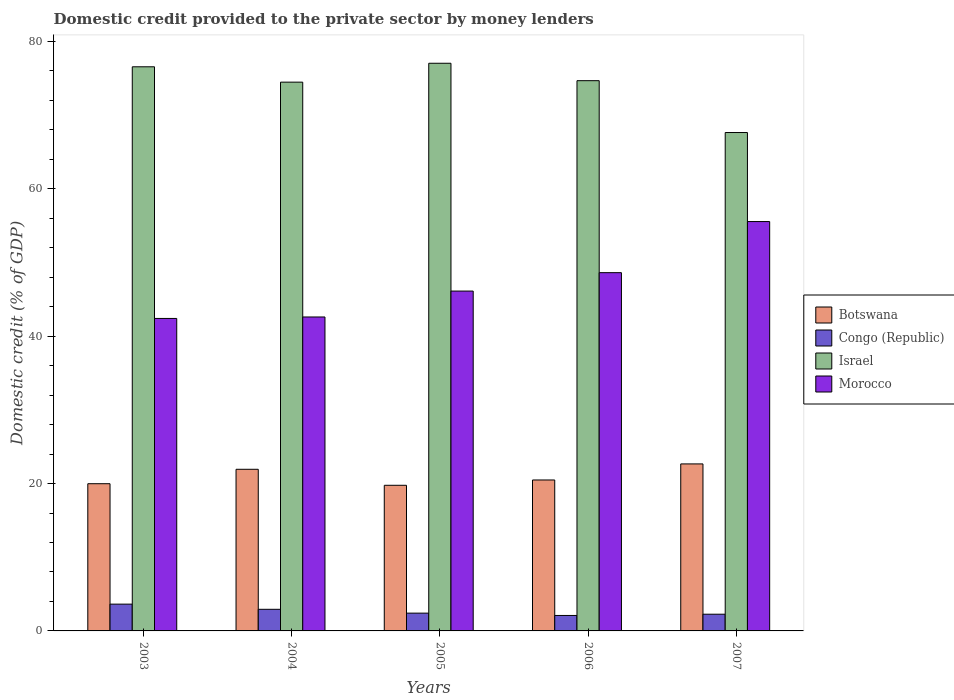How many different coloured bars are there?
Give a very brief answer. 4. Are the number of bars per tick equal to the number of legend labels?
Offer a very short reply. Yes. Are the number of bars on each tick of the X-axis equal?
Give a very brief answer. Yes. How many bars are there on the 1st tick from the left?
Provide a succinct answer. 4. How many bars are there on the 5th tick from the right?
Keep it short and to the point. 4. What is the label of the 4th group of bars from the left?
Keep it short and to the point. 2006. In how many cases, is the number of bars for a given year not equal to the number of legend labels?
Provide a short and direct response. 0. What is the domestic credit provided to the private sector by money lenders in Israel in 2006?
Your answer should be compact. 74.67. Across all years, what is the maximum domestic credit provided to the private sector by money lenders in Morocco?
Provide a succinct answer. 55.55. Across all years, what is the minimum domestic credit provided to the private sector by money lenders in Congo (Republic)?
Your answer should be very brief. 2.1. In which year was the domestic credit provided to the private sector by money lenders in Israel minimum?
Ensure brevity in your answer.  2007. What is the total domestic credit provided to the private sector by money lenders in Botswana in the graph?
Keep it short and to the point. 104.83. What is the difference between the domestic credit provided to the private sector by money lenders in Botswana in 2004 and that in 2007?
Provide a succinct answer. -0.73. What is the difference between the domestic credit provided to the private sector by money lenders in Congo (Republic) in 2007 and the domestic credit provided to the private sector by money lenders in Botswana in 2005?
Your answer should be very brief. -17.5. What is the average domestic credit provided to the private sector by money lenders in Congo (Republic) per year?
Your answer should be compact. 2.67. In the year 2003, what is the difference between the domestic credit provided to the private sector by money lenders in Congo (Republic) and domestic credit provided to the private sector by money lenders in Botswana?
Give a very brief answer. -16.34. In how many years, is the domestic credit provided to the private sector by money lenders in Morocco greater than 68 %?
Keep it short and to the point. 0. What is the ratio of the domestic credit provided to the private sector by money lenders in Israel in 2004 to that in 2005?
Your response must be concise. 0.97. Is the domestic credit provided to the private sector by money lenders in Morocco in 2004 less than that in 2007?
Offer a very short reply. Yes. Is the difference between the domestic credit provided to the private sector by money lenders in Congo (Republic) in 2004 and 2006 greater than the difference between the domestic credit provided to the private sector by money lenders in Botswana in 2004 and 2006?
Ensure brevity in your answer.  No. What is the difference between the highest and the second highest domestic credit provided to the private sector by money lenders in Congo (Republic)?
Offer a very short reply. 0.7. What is the difference between the highest and the lowest domestic credit provided to the private sector by money lenders in Morocco?
Give a very brief answer. 13.15. What does the 4th bar from the left in 2004 represents?
Provide a short and direct response. Morocco. Is it the case that in every year, the sum of the domestic credit provided to the private sector by money lenders in Botswana and domestic credit provided to the private sector by money lenders in Israel is greater than the domestic credit provided to the private sector by money lenders in Congo (Republic)?
Provide a short and direct response. Yes. How many bars are there?
Your answer should be compact. 20. Are all the bars in the graph horizontal?
Your answer should be compact. No. Are the values on the major ticks of Y-axis written in scientific E-notation?
Your answer should be very brief. No. Does the graph contain any zero values?
Provide a short and direct response. No. Where does the legend appear in the graph?
Offer a very short reply. Center right. What is the title of the graph?
Offer a very short reply. Domestic credit provided to the private sector by money lenders. Does "Pacific island small states" appear as one of the legend labels in the graph?
Ensure brevity in your answer.  No. What is the label or title of the Y-axis?
Offer a very short reply. Domestic credit (% of GDP). What is the Domestic credit (% of GDP) of Botswana in 2003?
Your answer should be compact. 19.98. What is the Domestic credit (% of GDP) in Congo (Republic) in 2003?
Ensure brevity in your answer.  3.64. What is the Domestic credit (% of GDP) in Israel in 2003?
Ensure brevity in your answer.  76.56. What is the Domestic credit (% of GDP) of Morocco in 2003?
Offer a terse response. 42.41. What is the Domestic credit (% of GDP) in Botswana in 2004?
Ensure brevity in your answer.  21.94. What is the Domestic credit (% of GDP) of Congo (Republic) in 2004?
Ensure brevity in your answer.  2.93. What is the Domestic credit (% of GDP) in Israel in 2004?
Ensure brevity in your answer.  74.47. What is the Domestic credit (% of GDP) in Morocco in 2004?
Offer a very short reply. 42.6. What is the Domestic credit (% of GDP) in Botswana in 2005?
Your response must be concise. 19.76. What is the Domestic credit (% of GDP) in Congo (Republic) in 2005?
Provide a succinct answer. 2.41. What is the Domestic credit (% of GDP) in Israel in 2005?
Your answer should be very brief. 77.04. What is the Domestic credit (% of GDP) in Morocco in 2005?
Your response must be concise. 46.12. What is the Domestic credit (% of GDP) in Botswana in 2006?
Make the answer very short. 20.48. What is the Domestic credit (% of GDP) of Congo (Republic) in 2006?
Provide a short and direct response. 2.1. What is the Domestic credit (% of GDP) of Israel in 2006?
Provide a short and direct response. 74.67. What is the Domestic credit (% of GDP) in Morocco in 2006?
Offer a very short reply. 48.62. What is the Domestic credit (% of GDP) in Botswana in 2007?
Ensure brevity in your answer.  22.66. What is the Domestic credit (% of GDP) in Congo (Republic) in 2007?
Your answer should be compact. 2.27. What is the Domestic credit (% of GDP) in Israel in 2007?
Your answer should be very brief. 67.64. What is the Domestic credit (% of GDP) in Morocco in 2007?
Provide a short and direct response. 55.55. Across all years, what is the maximum Domestic credit (% of GDP) in Botswana?
Offer a very short reply. 22.66. Across all years, what is the maximum Domestic credit (% of GDP) in Congo (Republic)?
Your response must be concise. 3.64. Across all years, what is the maximum Domestic credit (% of GDP) of Israel?
Ensure brevity in your answer.  77.04. Across all years, what is the maximum Domestic credit (% of GDP) of Morocco?
Ensure brevity in your answer.  55.55. Across all years, what is the minimum Domestic credit (% of GDP) of Botswana?
Provide a short and direct response. 19.76. Across all years, what is the minimum Domestic credit (% of GDP) in Congo (Republic)?
Provide a succinct answer. 2.1. Across all years, what is the minimum Domestic credit (% of GDP) of Israel?
Give a very brief answer. 67.64. Across all years, what is the minimum Domestic credit (% of GDP) in Morocco?
Offer a very short reply. 42.41. What is the total Domestic credit (% of GDP) in Botswana in the graph?
Your answer should be compact. 104.83. What is the total Domestic credit (% of GDP) in Congo (Republic) in the graph?
Keep it short and to the point. 13.35. What is the total Domestic credit (% of GDP) of Israel in the graph?
Your answer should be very brief. 370.38. What is the total Domestic credit (% of GDP) of Morocco in the graph?
Make the answer very short. 235.31. What is the difference between the Domestic credit (% of GDP) in Botswana in 2003 and that in 2004?
Your response must be concise. -1.96. What is the difference between the Domestic credit (% of GDP) of Congo (Republic) in 2003 and that in 2004?
Your response must be concise. 0.7. What is the difference between the Domestic credit (% of GDP) in Israel in 2003 and that in 2004?
Your answer should be very brief. 2.08. What is the difference between the Domestic credit (% of GDP) in Morocco in 2003 and that in 2004?
Keep it short and to the point. -0.2. What is the difference between the Domestic credit (% of GDP) of Botswana in 2003 and that in 2005?
Make the answer very short. 0.21. What is the difference between the Domestic credit (% of GDP) of Congo (Republic) in 2003 and that in 2005?
Your answer should be compact. 1.22. What is the difference between the Domestic credit (% of GDP) in Israel in 2003 and that in 2005?
Ensure brevity in your answer.  -0.48. What is the difference between the Domestic credit (% of GDP) in Morocco in 2003 and that in 2005?
Offer a terse response. -3.71. What is the difference between the Domestic credit (% of GDP) in Botswana in 2003 and that in 2006?
Keep it short and to the point. -0.51. What is the difference between the Domestic credit (% of GDP) in Congo (Republic) in 2003 and that in 2006?
Make the answer very short. 1.54. What is the difference between the Domestic credit (% of GDP) of Israel in 2003 and that in 2006?
Your answer should be compact. 1.88. What is the difference between the Domestic credit (% of GDP) of Morocco in 2003 and that in 2006?
Offer a very short reply. -6.21. What is the difference between the Domestic credit (% of GDP) in Botswana in 2003 and that in 2007?
Your answer should be very brief. -2.69. What is the difference between the Domestic credit (% of GDP) of Congo (Republic) in 2003 and that in 2007?
Keep it short and to the point. 1.37. What is the difference between the Domestic credit (% of GDP) of Israel in 2003 and that in 2007?
Make the answer very short. 8.92. What is the difference between the Domestic credit (% of GDP) of Morocco in 2003 and that in 2007?
Your response must be concise. -13.15. What is the difference between the Domestic credit (% of GDP) in Botswana in 2004 and that in 2005?
Ensure brevity in your answer.  2.17. What is the difference between the Domestic credit (% of GDP) of Congo (Republic) in 2004 and that in 2005?
Provide a short and direct response. 0.52. What is the difference between the Domestic credit (% of GDP) in Israel in 2004 and that in 2005?
Ensure brevity in your answer.  -2.56. What is the difference between the Domestic credit (% of GDP) of Morocco in 2004 and that in 2005?
Your answer should be compact. -3.52. What is the difference between the Domestic credit (% of GDP) in Botswana in 2004 and that in 2006?
Offer a terse response. 1.45. What is the difference between the Domestic credit (% of GDP) in Congo (Republic) in 2004 and that in 2006?
Offer a terse response. 0.84. What is the difference between the Domestic credit (% of GDP) of Morocco in 2004 and that in 2006?
Give a very brief answer. -6.02. What is the difference between the Domestic credit (% of GDP) in Botswana in 2004 and that in 2007?
Ensure brevity in your answer.  -0.73. What is the difference between the Domestic credit (% of GDP) in Congo (Republic) in 2004 and that in 2007?
Ensure brevity in your answer.  0.67. What is the difference between the Domestic credit (% of GDP) of Israel in 2004 and that in 2007?
Keep it short and to the point. 6.84. What is the difference between the Domestic credit (% of GDP) in Morocco in 2004 and that in 2007?
Make the answer very short. -12.95. What is the difference between the Domestic credit (% of GDP) in Botswana in 2005 and that in 2006?
Provide a short and direct response. -0.72. What is the difference between the Domestic credit (% of GDP) in Congo (Republic) in 2005 and that in 2006?
Provide a succinct answer. 0.32. What is the difference between the Domestic credit (% of GDP) of Israel in 2005 and that in 2006?
Keep it short and to the point. 2.36. What is the difference between the Domestic credit (% of GDP) in Morocco in 2005 and that in 2006?
Make the answer very short. -2.5. What is the difference between the Domestic credit (% of GDP) in Botswana in 2005 and that in 2007?
Provide a short and direct response. -2.9. What is the difference between the Domestic credit (% of GDP) in Congo (Republic) in 2005 and that in 2007?
Keep it short and to the point. 0.15. What is the difference between the Domestic credit (% of GDP) in Israel in 2005 and that in 2007?
Provide a succinct answer. 9.4. What is the difference between the Domestic credit (% of GDP) of Morocco in 2005 and that in 2007?
Your response must be concise. -9.43. What is the difference between the Domestic credit (% of GDP) in Botswana in 2006 and that in 2007?
Provide a short and direct response. -2.18. What is the difference between the Domestic credit (% of GDP) of Congo (Republic) in 2006 and that in 2007?
Provide a short and direct response. -0.17. What is the difference between the Domestic credit (% of GDP) in Israel in 2006 and that in 2007?
Your response must be concise. 7.04. What is the difference between the Domestic credit (% of GDP) of Morocco in 2006 and that in 2007?
Keep it short and to the point. -6.93. What is the difference between the Domestic credit (% of GDP) of Botswana in 2003 and the Domestic credit (% of GDP) of Congo (Republic) in 2004?
Ensure brevity in your answer.  17.04. What is the difference between the Domestic credit (% of GDP) of Botswana in 2003 and the Domestic credit (% of GDP) of Israel in 2004?
Offer a very short reply. -54.5. What is the difference between the Domestic credit (% of GDP) in Botswana in 2003 and the Domestic credit (% of GDP) in Morocco in 2004?
Your answer should be compact. -22.63. What is the difference between the Domestic credit (% of GDP) in Congo (Republic) in 2003 and the Domestic credit (% of GDP) in Israel in 2004?
Provide a short and direct response. -70.84. What is the difference between the Domestic credit (% of GDP) in Congo (Republic) in 2003 and the Domestic credit (% of GDP) in Morocco in 2004?
Your answer should be compact. -38.97. What is the difference between the Domestic credit (% of GDP) in Israel in 2003 and the Domestic credit (% of GDP) in Morocco in 2004?
Offer a terse response. 33.95. What is the difference between the Domestic credit (% of GDP) in Botswana in 2003 and the Domestic credit (% of GDP) in Congo (Republic) in 2005?
Keep it short and to the point. 17.56. What is the difference between the Domestic credit (% of GDP) in Botswana in 2003 and the Domestic credit (% of GDP) in Israel in 2005?
Provide a short and direct response. -57.06. What is the difference between the Domestic credit (% of GDP) in Botswana in 2003 and the Domestic credit (% of GDP) in Morocco in 2005?
Provide a succinct answer. -26.14. What is the difference between the Domestic credit (% of GDP) of Congo (Republic) in 2003 and the Domestic credit (% of GDP) of Israel in 2005?
Offer a very short reply. -73.4. What is the difference between the Domestic credit (% of GDP) in Congo (Republic) in 2003 and the Domestic credit (% of GDP) in Morocco in 2005?
Offer a very short reply. -42.48. What is the difference between the Domestic credit (% of GDP) of Israel in 2003 and the Domestic credit (% of GDP) of Morocco in 2005?
Provide a succinct answer. 30.44. What is the difference between the Domestic credit (% of GDP) in Botswana in 2003 and the Domestic credit (% of GDP) in Congo (Republic) in 2006?
Provide a succinct answer. 17.88. What is the difference between the Domestic credit (% of GDP) in Botswana in 2003 and the Domestic credit (% of GDP) in Israel in 2006?
Ensure brevity in your answer.  -54.7. What is the difference between the Domestic credit (% of GDP) in Botswana in 2003 and the Domestic credit (% of GDP) in Morocco in 2006?
Keep it short and to the point. -28.64. What is the difference between the Domestic credit (% of GDP) of Congo (Republic) in 2003 and the Domestic credit (% of GDP) of Israel in 2006?
Your answer should be compact. -71.04. What is the difference between the Domestic credit (% of GDP) in Congo (Republic) in 2003 and the Domestic credit (% of GDP) in Morocco in 2006?
Give a very brief answer. -44.98. What is the difference between the Domestic credit (% of GDP) of Israel in 2003 and the Domestic credit (% of GDP) of Morocco in 2006?
Your answer should be very brief. 27.94. What is the difference between the Domestic credit (% of GDP) in Botswana in 2003 and the Domestic credit (% of GDP) in Congo (Republic) in 2007?
Offer a very short reply. 17.71. What is the difference between the Domestic credit (% of GDP) of Botswana in 2003 and the Domestic credit (% of GDP) of Israel in 2007?
Offer a very short reply. -47.66. What is the difference between the Domestic credit (% of GDP) in Botswana in 2003 and the Domestic credit (% of GDP) in Morocco in 2007?
Ensure brevity in your answer.  -35.58. What is the difference between the Domestic credit (% of GDP) of Congo (Republic) in 2003 and the Domestic credit (% of GDP) of Israel in 2007?
Your answer should be compact. -64. What is the difference between the Domestic credit (% of GDP) of Congo (Republic) in 2003 and the Domestic credit (% of GDP) of Morocco in 2007?
Your answer should be compact. -51.92. What is the difference between the Domestic credit (% of GDP) of Israel in 2003 and the Domestic credit (% of GDP) of Morocco in 2007?
Give a very brief answer. 21. What is the difference between the Domestic credit (% of GDP) of Botswana in 2004 and the Domestic credit (% of GDP) of Congo (Republic) in 2005?
Your answer should be compact. 19.52. What is the difference between the Domestic credit (% of GDP) of Botswana in 2004 and the Domestic credit (% of GDP) of Israel in 2005?
Give a very brief answer. -55.1. What is the difference between the Domestic credit (% of GDP) in Botswana in 2004 and the Domestic credit (% of GDP) in Morocco in 2005?
Ensure brevity in your answer.  -24.18. What is the difference between the Domestic credit (% of GDP) in Congo (Republic) in 2004 and the Domestic credit (% of GDP) in Israel in 2005?
Your response must be concise. -74.11. What is the difference between the Domestic credit (% of GDP) in Congo (Republic) in 2004 and the Domestic credit (% of GDP) in Morocco in 2005?
Give a very brief answer. -43.19. What is the difference between the Domestic credit (% of GDP) of Israel in 2004 and the Domestic credit (% of GDP) of Morocco in 2005?
Provide a succinct answer. 28.35. What is the difference between the Domestic credit (% of GDP) of Botswana in 2004 and the Domestic credit (% of GDP) of Congo (Republic) in 2006?
Provide a succinct answer. 19.84. What is the difference between the Domestic credit (% of GDP) of Botswana in 2004 and the Domestic credit (% of GDP) of Israel in 2006?
Offer a very short reply. -52.74. What is the difference between the Domestic credit (% of GDP) in Botswana in 2004 and the Domestic credit (% of GDP) in Morocco in 2006?
Offer a terse response. -26.68. What is the difference between the Domestic credit (% of GDP) of Congo (Republic) in 2004 and the Domestic credit (% of GDP) of Israel in 2006?
Your answer should be very brief. -71.74. What is the difference between the Domestic credit (% of GDP) of Congo (Republic) in 2004 and the Domestic credit (% of GDP) of Morocco in 2006?
Your answer should be compact. -45.69. What is the difference between the Domestic credit (% of GDP) of Israel in 2004 and the Domestic credit (% of GDP) of Morocco in 2006?
Provide a succinct answer. 25.85. What is the difference between the Domestic credit (% of GDP) in Botswana in 2004 and the Domestic credit (% of GDP) in Congo (Republic) in 2007?
Keep it short and to the point. 19.67. What is the difference between the Domestic credit (% of GDP) of Botswana in 2004 and the Domestic credit (% of GDP) of Israel in 2007?
Ensure brevity in your answer.  -45.7. What is the difference between the Domestic credit (% of GDP) in Botswana in 2004 and the Domestic credit (% of GDP) in Morocco in 2007?
Offer a very short reply. -33.62. What is the difference between the Domestic credit (% of GDP) in Congo (Republic) in 2004 and the Domestic credit (% of GDP) in Israel in 2007?
Ensure brevity in your answer.  -64.71. What is the difference between the Domestic credit (% of GDP) in Congo (Republic) in 2004 and the Domestic credit (% of GDP) in Morocco in 2007?
Give a very brief answer. -52.62. What is the difference between the Domestic credit (% of GDP) of Israel in 2004 and the Domestic credit (% of GDP) of Morocco in 2007?
Ensure brevity in your answer.  18.92. What is the difference between the Domestic credit (% of GDP) in Botswana in 2005 and the Domestic credit (% of GDP) in Congo (Republic) in 2006?
Your answer should be very brief. 17.67. What is the difference between the Domestic credit (% of GDP) of Botswana in 2005 and the Domestic credit (% of GDP) of Israel in 2006?
Ensure brevity in your answer.  -54.91. What is the difference between the Domestic credit (% of GDP) in Botswana in 2005 and the Domestic credit (% of GDP) in Morocco in 2006?
Give a very brief answer. -28.86. What is the difference between the Domestic credit (% of GDP) of Congo (Republic) in 2005 and the Domestic credit (% of GDP) of Israel in 2006?
Ensure brevity in your answer.  -72.26. What is the difference between the Domestic credit (% of GDP) in Congo (Republic) in 2005 and the Domestic credit (% of GDP) in Morocco in 2006?
Provide a succinct answer. -46.21. What is the difference between the Domestic credit (% of GDP) of Israel in 2005 and the Domestic credit (% of GDP) of Morocco in 2006?
Your response must be concise. 28.42. What is the difference between the Domestic credit (% of GDP) of Botswana in 2005 and the Domestic credit (% of GDP) of Congo (Republic) in 2007?
Your answer should be compact. 17.5. What is the difference between the Domestic credit (% of GDP) of Botswana in 2005 and the Domestic credit (% of GDP) of Israel in 2007?
Make the answer very short. -47.88. What is the difference between the Domestic credit (% of GDP) of Botswana in 2005 and the Domestic credit (% of GDP) of Morocco in 2007?
Provide a short and direct response. -35.79. What is the difference between the Domestic credit (% of GDP) of Congo (Republic) in 2005 and the Domestic credit (% of GDP) of Israel in 2007?
Your response must be concise. -65.22. What is the difference between the Domestic credit (% of GDP) of Congo (Republic) in 2005 and the Domestic credit (% of GDP) of Morocco in 2007?
Make the answer very short. -53.14. What is the difference between the Domestic credit (% of GDP) in Israel in 2005 and the Domestic credit (% of GDP) in Morocco in 2007?
Your answer should be compact. 21.48. What is the difference between the Domestic credit (% of GDP) of Botswana in 2006 and the Domestic credit (% of GDP) of Congo (Republic) in 2007?
Provide a succinct answer. 18.22. What is the difference between the Domestic credit (% of GDP) of Botswana in 2006 and the Domestic credit (% of GDP) of Israel in 2007?
Your answer should be very brief. -47.15. What is the difference between the Domestic credit (% of GDP) of Botswana in 2006 and the Domestic credit (% of GDP) of Morocco in 2007?
Provide a short and direct response. -35.07. What is the difference between the Domestic credit (% of GDP) in Congo (Republic) in 2006 and the Domestic credit (% of GDP) in Israel in 2007?
Provide a succinct answer. -65.54. What is the difference between the Domestic credit (% of GDP) of Congo (Republic) in 2006 and the Domestic credit (% of GDP) of Morocco in 2007?
Your answer should be very brief. -53.46. What is the difference between the Domestic credit (% of GDP) in Israel in 2006 and the Domestic credit (% of GDP) in Morocco in 2007?
Give a very brief answer. 19.12. What is the average Domestic credit (% of GDP) in Botswana per year?
Provide a succinct answer. 20.97. What is the average Domestic credit (% of GDP) in Congo (Republic) per year?
Provide a succinct answer. 2.67. What is the average Domestic credit (% of GDP) of Israel per year?
Offer a terse response. 74.08. What is the average Domestic credit (% of GDP) of Morocco per year?
Provide a succinct answer. 47.06. In the year 2003, what is the difference between the Domestic credit (% of GDP) of Botswana and Domestic credit (% of GDP) of Congo (Republic)?
Keep it short and to the point. 16.34. In the year 2003, what is the difference between the Domestic credit (% of GDP) in Botswana and Domestic credit (% of GDP) in Israel?
Provide a short and direct response. -56.58. In the year 2003, what is the difference between the Domestic credit (% of GDP) in Botswana and Domestic credit (% of GDP) in Morocco?
Make the answer very short. -22.43. In the year 2003, what is the difference between the Domestic credit (% of GDP) of Congo (Republic) and Domestic credit (% of GDP) of Israel?
Provide a short and direct response. -72.92. In the year 2003, what is the difference between the Domestic credit (% of GDP) of Congo (Republic) and Domestic credit (% of GDP) of Morocco?
Make the answer very short. -38.77. In the year 2003, what is the difference between the Domestic credit (% of GDP) in Israel and Domestic credit (% of GDP) in Morocco?
Offer a terse response. 34.15. In the year 2004, what is the difference between the Domestic credit (% of GDP) in Botswana and Domestic credit (% of GDP) in Congo (Republic)?
Your answer should be compact. 19. In the year 2004, what is the difference between the Domestic credit (% of GDP) in Botswana and Domestic credit (% of GDP) in Israel?
Provide a short and direct response. -52.54. In the year 2004, what is the difference between the Domestic credit (% of GDP) in Botswana and Domestic credit (% of GDP) in Morocco?
Ensure brevity in your answer.  -20.67. In the year 2004, what is the difference between the Domestic credit (% of GDP) in Congo (Republic) and Domestic credit (% of GDP) in Israel?
Ensure brevity in your answer.  -71.54. In the year 2004, what is the difference between the Domestic credit (% of GDP) in Congo (Republic) and Domestic credit (% of GDP) in Morocco?
Offer a terse response. -39.67. In the year 2004, what is the difference between the Domestic credit (% of GDP) in Israel and Domestic credit (% of GDP) in Morocco?
Make the answer very short. 31.87. In the year 2005, what is the difference between the Domestic credit (% of GDP) of Botswana and Domestic credit (% of GDP) of Congo (Republic)?
Your answer should be compact. 17.35. In the year 2005, what is the difference between the Domestic credit (% of GDP) in Botswana and Domestic credit (% of GDP) in Israel?
Provide a short and direct response. -57.27. In the year 2005, what is the difference between the Domestic credit (% of GDP) of Botswana and Domestic credit (% of GDP) of Morocco?
Offer a very short reply. -26.36. In the year 2005, what is the difference between the Domestic credit (% of GDP) of Congo (Republic) and Domestic credit (% of GDP) of Israel?
Give a very brief answer. -74.62. In the year 2005, what is the difference between the Domestic credit (% of GDP) in Congo (Republic) and Domestic credit (% of GDP) in Morocco?
Keep it short and to the point. -43.71. In the year 2005, what is the difference between the Domestic credit (% of GDP) in Israel and Domestic credit (% of GDP) in Morocco?
Provide a succinct answer. 30.92. In the year 2006, what is the difference between the Domestic credit (% of GDP) in Botswana and Domestic credit (% of GDP) in Congo (Republic)?
Provide a short and direct response. 18.39. In the year 2006, what is the difference between the Domestic credit (% of GDP) in Botswana and Domestic credit (% of GDP) in Israel?
Provide a short and direct response. -54.19. In the year 2006, what is the difference between the Domestic credit (% of GDP) of Botswana and Domestic credit (% of GDP) of Morocco?
Ensure brevity in your answer.  -28.14. In the year 2006, what is the difference between the Domestic credit (% of GDP) of Congo (Republic) and Domestic credit (% of GDP) of Israel?
Your answer should be very brief. -72.58. In the year 2006, what is the difference between the Domestic credit (% of GDP) in Congo (Republic) and Domestic credit (% of GDP) in Morocco?
Your answer should be very brief. -46.52. In the year 2006, what is the difference between the Domestic credit (% of GDP) of Israel and Domestic credit (% of GDP) of Morocco?
Keep it short and to the point. 26.05. In the year 2007, what is the difference between the Domestic credit (% of GDP) in Botswana and Domestic credit (% of GDP) in Congo (Republic)?
Keep it short and to the point. 20.4. In the year 2007, what is the difference between the Domestic credit (% of GDP) of Botswana and Domestic credit (% of GDP) of Israel?
Your answer should be compact. -44.97. In the year 2007, what is the difference between the Domestic credit (% of GDP) in Botswana and Domestic credit (% of GDP) in Morocco?
Ensure brevity in your answer.  -32.89. In the year 2007, what is the difference between the Domestic credit (% of GDP) of Congo (Republic) and Domestic credit (% of GDP) of Israel?
Keep it short and to the point. -65.37. In the year 2007, what is the difference between the Domestic credit (% of GDP) of Congo (Republic) and Domestic credit (% of GDP) of Morocco?
Provide a succinct answer. -53.29. In the year 2007, what is the difference between the Domestic credit (% of GDP) of Israel and Domestic credit (% of GDP) of Morocco?
Offer a very short reply. 12.08. What is the ratio of the Domestic credit (% of GDP) in Botswana in 2003 to that in 2004?
Your answer should be compact. 0.91. What is the ratio of the Domestic credit (% of GDP) of Congo (Republic) in 2003 to that in 2004?
Offer a terse response. 1.24. What is the ratio of the Domestic credit (% of GDP) of Israel in 2003 to that in 2004?
Offer a terse response. 1.03. What is the ratio of the Domestic credit (% of GDP) in Morocco in 2003 to that in 2004?
Your answer should be compact. 1. What is the ratio of the Domestic credit (% of GDP) in Botswana in 2003 to that in 2005?
Your answer should be compact. 1.01. What is the ratio of the Domestic credit (% of GDP) of Congo (Republic) in 2003 to that in 2005?
Keep it short and to the point. 1.51. What is the ratio of the Domestic credit (% of GDP) in Morocco in 2003 to that in 2005?
Offer a terse response. 0.92. What is the ratio of the Domestic credit (% of GDP) in Botswana in 2003 to that in 2006?
Your response must be concise. 0.98. What is the ratio of the Domestic credit (% of GDP) of Congo (Republic) in 2003 to that in 2006?
Your answer should be compact. 1.73. What is the ratio of the Domestic credit (% of GDP) in Israel in 2003 to that in 2006?
Your answer should be very brief. 1.03. What is the ratio of the Domestic credit (% of GDP) in Morocco in 2003 to that in 2006?
Make the answer very short. 0.87. What is the ratio of the Domestic credit (% of GDP) in Botswana in 2003 to that in 2007?
Provide a short and direct response. 0.88. What is the ratio of the Domestic credit (% of GDP) of Congo (Republic) in 2003 to that in 2007?
Your response must be concise. 1.6. What is the ratio of the Domestic credit (% of GDP) of Israel in 2003 to that in 2007?
Offer a very short reply. 1.13. What is the ratio of the Domestic credit (% of GDP) of Morocco in 2003 to that in 2007?
Offer a terse response. 0.76. What is the ratio of the Domestic credit (% of GDP) of Botswana in 2004 to that in 2005?
Provide a short and direct response. 1.11. What is the ratio of the Domestic credit (% of GDP) in Congo (Republic) in 2004 to that in 2005?
Your answer should be compact. 1.21. What is the ratio of the Domestic credit (% of GDP) in Israel in 2004 to that in 2005?
Your response must be concise. 0.97. What is the ratio of the Domestic credit (% of GDP) of Morocco in 2004 to that in 2005?
Ensure brevity in your answer.  0.92. What is the ratio of the Domestic credit (% of GDP) in Botswana in 2004 to that in 2006?
Provide a short and direct response. 1.07. What is the ratio of the Domestic credit (% of GDP) of Congo (Republic) in 2004 to that in 2006?
Offer a very short reply. 1.4. What is the ratio of the Domestic credit (% of GDP) of Morocco in 2004 to that in 2006?
Give a very brief answer. 0.88. What is the ratio of the Domestic credit (% of GDP) in Botswana in 2004 to that in 2007?
Your answer should be very brief. 0.97. What is the ratio of the Domestic credit (% of GDP) of Congo (Republic) in 2004 to that in 2007?
Keep it short and to the point. 1.29. What is the ratio of the Domestic credit (% of GDP) in Israel in 2004 to that in 2007?
Your answer should be very brief. 1.1. What is the ratio of the Domestic credit (% of GDP) in Morocco in 2004 to that in 2007?
Provide a succinct answer. 0.77. What is the ratio of the Domestic credit (% of GDP) of Botswana in 2005 to that in 2006?
Ensure brevity in your answer.  0.96. What is the ratio of the Domestic credit (% of GDP) in Congo (Republic) in 2005 to that in 2006?
Your answer should be compact. 1.15. What is the ratio of the Domestic credit (% of GDP) of Israel in 2005 to that in 2006?
Offer a very short reply. 1.03. What is the ratio of the Domestic credit (% of GDP) in Morocco in 2005 to that in 2006?
Offer a very short reply. 0.95. What is the ratio of the Domestic credit (% of GDP) of Botswana in 2005 to that in 2007?
Offer a terse response. 0.87. What is the ratio of the Domestic credit (% of GDP) in Congo (Republic) in 2005 to that in 2007?
Make the answer very short. 1.06. What is the ratio of the Domestic credit (% of GDP) of Israel in 2005 to that in 2007?
Your answer should be very brief. 1.14. What is the ratio of the Domestic credit (% of GDP) in Morocco in 2005 to that in 2007?
Offer a terse response. 0.83. What is the ratio of the Domestic credit (% of GDP) in Botswana in 2006 to that in 2007?
Make the answer very short. 0.9. What is the ratio of the Domestic credit (% of GDP) in Congo (Republic) in 2006 to that in 2007?
Provide a short and direct response. 0.93. What is the ratio of the Domestic credit (% of GDP) of Israel in 2006 to that in 2007?
Your answer should be very brief. 1.1. What is the ratio of the Domestic credit (% of GDP) in Morocco in 2006 to that in 2007?
Provide a succinct answer. 0.88. What is the difference between the highest and the second highest Domestic credit (% of GDP) in Botswana?
Give a very brief answer. 0.73. What is the difference between the highest and the second highest Domestic credit (% of GDP) of Congo (Republic)?
Keep it short and to the point. 0.7. What is the difference between the highest and the second highest Domestic credit (% of GDP) of Israel?
Your answer should be compact. 0.48. What is the difference between the highest and the second highest Domestic credit (% of GDP) in Morocco?
Provide a short and direct response. 6.93. What is the difference between the highest and the lowest Domestic credit (% of GDP) of Botswana?
Ensure brevity in your answer.  2.9. What is the difference between the highest and the lowest Domestic credit (% of GDP) in Congo (Republic)?
Offer a very short reply. 1.54. What is the difference between the highest and the lowest Domestic credit (% of GDP) of Israel?
Your answer should be compact. 9.4. What is the difference between the highest and the lowest Domestic credit (% of GDP) of Morocco?
Your answer should be compact. 13.15. 